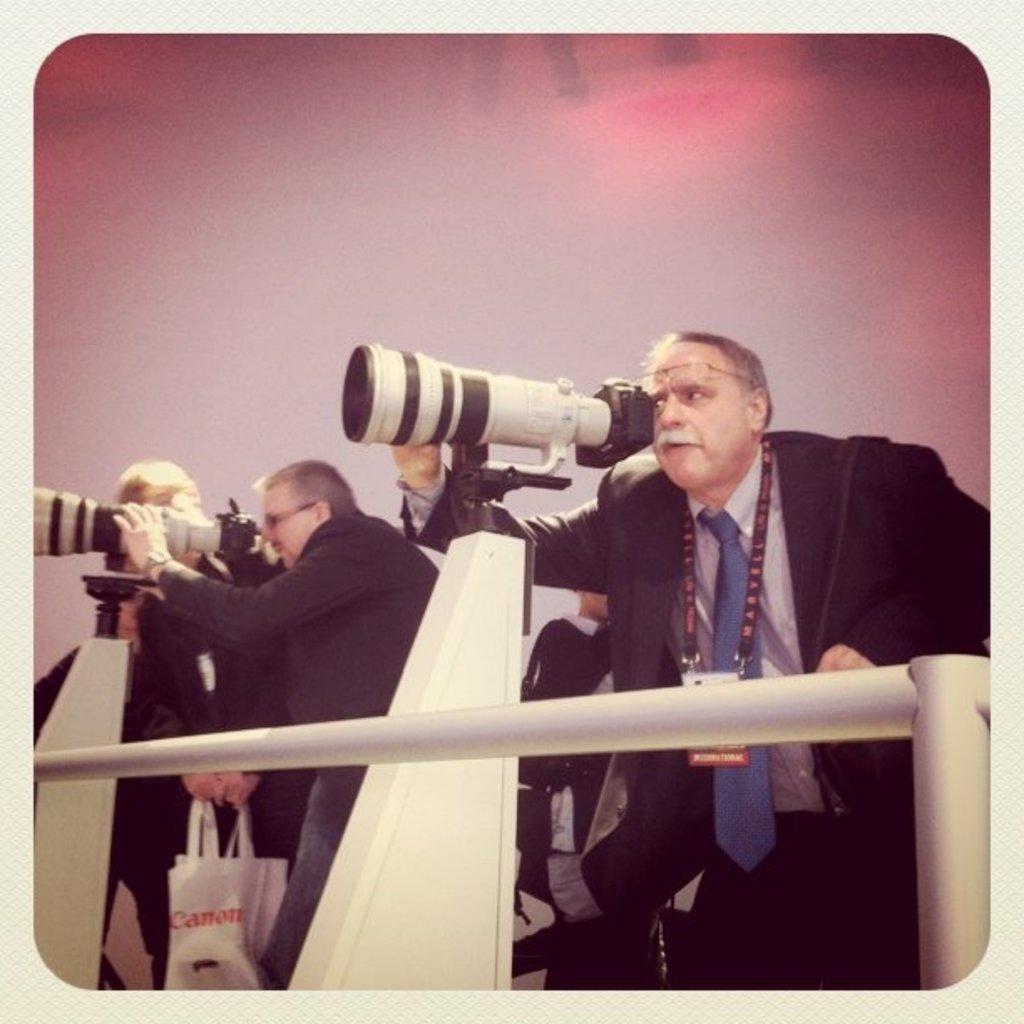Can you describe this image briefly? This is a picture. In this picture we can see men standing and some of them are peeping through the camera with lens placed on the stands. 